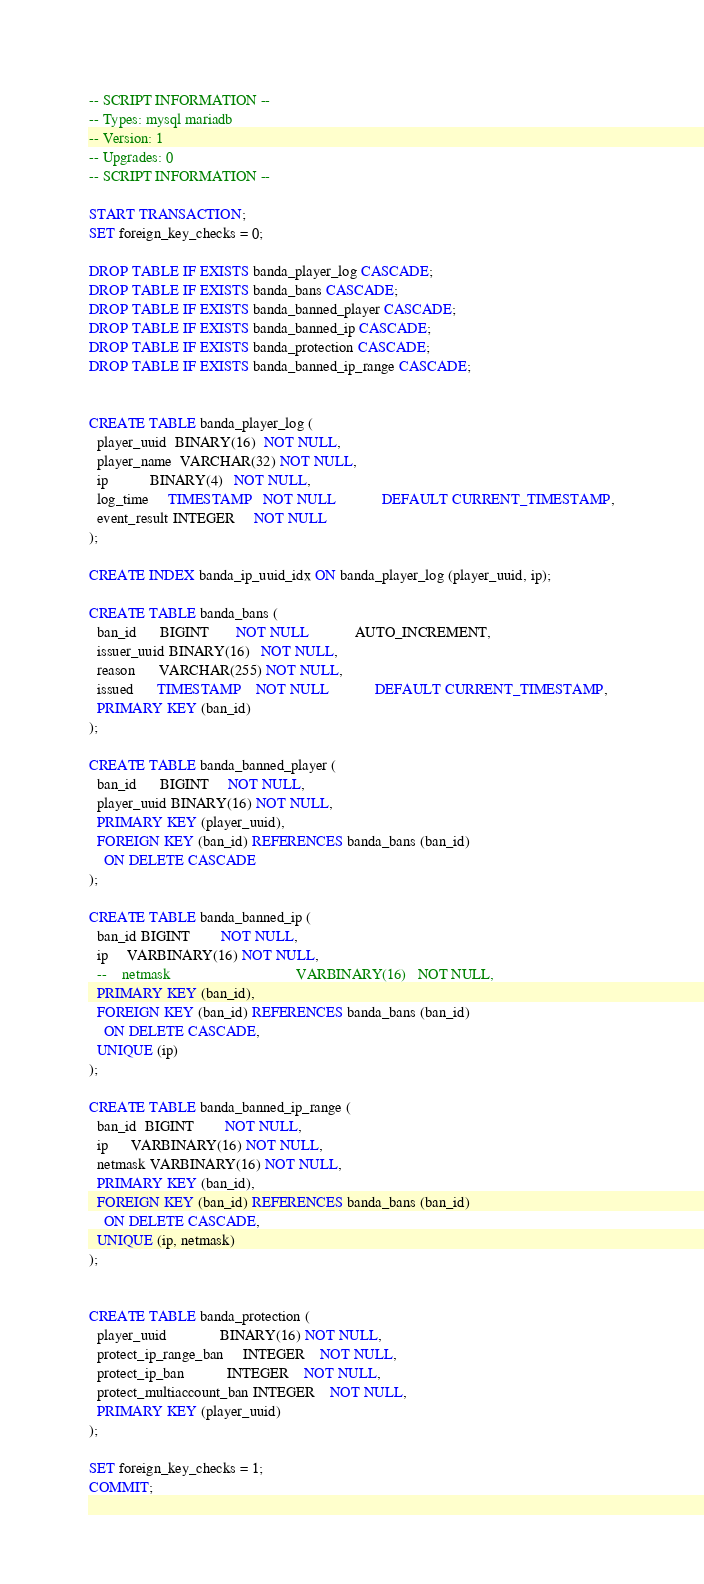<code> <loc_0><loc_0><loc_500><loc_500><_SQL_>-- SCRIPT INFORMATION --
-- Types: mysql mariadb
-- Version: 1
-- Upgrades: 0
-- SCRIPT INFORMATION --

START TRANSACTION;
SET foreign_key_checks = 0;

DROP TABLE IF EXISTS banda_player_log CASCADE;
DROP TABLE IF EXISTS banda_bans CASCADE;
DROP TABLE IF EXISTS banda_banned_player CASCADE;
DROP TABLE IF EXISTS banda_banned_ip CASCADE;
DROP TABLE IF EXISTS banda_protection CASCADE;
DROP TABLE IF EXISTS banda_banned_ip_range CASCADE;


CREATE TABLE banda_player_log (
  player_uuid  BINARY(16)  NOT NULL,
  player_name  VARCHAR(32) NOT NULL,
  ip           BINARY(4)   NOT NULL,
  log_time     TIMESTAMP   NOT NULL            DEFAULT CURRENT_TIMESTAMP,
  event_result INTEGER     NOT NULL
);

CREATE INDEX banda_ip_uuid_idx ON banda_player_log (player_uuid, ip);

CREATE TABLE banda_bans (
  ban_id      BIGINT       NOT NULL            AUTO_INCREMENT,
  issuer_uuid BINARY(16)   NOT NULL,
  reason      VARCHAR(255) NOT NULL,
  issued      TIMESTAMP    NOT NULL            DEFAULT CURRENT_TIMESTAMP,
  PRIMARY KEY (ban_id)
);

CREATE TABLE banda_banned_player (
  ban_id      BIGINT     NOT NULL,
  player_uuid BINARY(16) NOT NULL,
  PRIMARY KEY (player_uuid),
  FOREIGN KEY (ban_id) REFERENCES banda_bans (ban_id)
    ON DELETE CASCADE
);

CREATE TABLE banda_banned_ip (
  ban_id BIGINT        NOT NULL,
  ip     VARBINARY(16) NOT NULL,
  --    netmask                                 VARBINARY(16)   NOT NULL,
  PRIMARY KEY (ban_id),
  FOREIGN KEY (ban_id) REFERENCES banda_bans (ban_id)
    ON DELETE CASCADE,
  UNIQUE (ip)
);

CREATE TABLE banda_banned_ip_range (
  ban_id  BIGINT        NOT NULL,
  ip      VARBINARY(16) NOT NULL,
  netmask VARBINARY(16) NOT NULL,
  PRIMARY KEY (ban_id),
  FOREIGN KEY (ban_id) REFERENCES banda_bans (ban_id)
    ON DELETE CASCADE,
  UNIQUE (ip, netmask)
);


CREATE TABLE banda_protection (
  player_uuid              BINARY(16) NOT NULL,
  protect_ip_range_ban     INTEGER    NOT NULL,
  protect_ip_ban           INTEGER    NOT NULL,
  protect_multiaccount_ban INTEGER    NOT NULL,
  PRIMARY KEY (player_uuid)
);

SET foreign_key_checks = 1;
COMMIT;</code> 